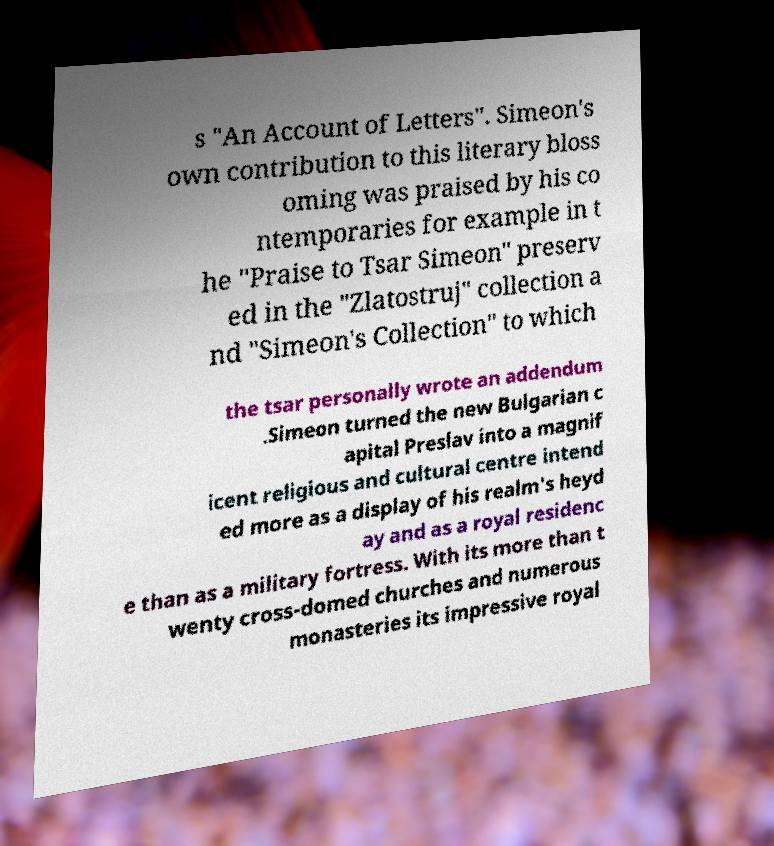There's text embedded in this image that I need extracted. Can you transcribe it verbatim? s "An Account of Letters". Simeon's own contribution to this literary bloss oming was praised by his co ntemporaries for example in t he "Praise to Tsar Simeon" preserv ed in the "Zlatostruj" collection a nd "Simeon's Collection" to which the tsar personally wrote an addendum .Simeon turned the new Bulgarian c apital Preslav into a magnif icent religious and cultural centre intend ed more as a display of his realm's heyd ay and as a royal residenc e than as a military fortress. With its more than t wenty cross-domed churches and numerous monasteries its impressive royal 